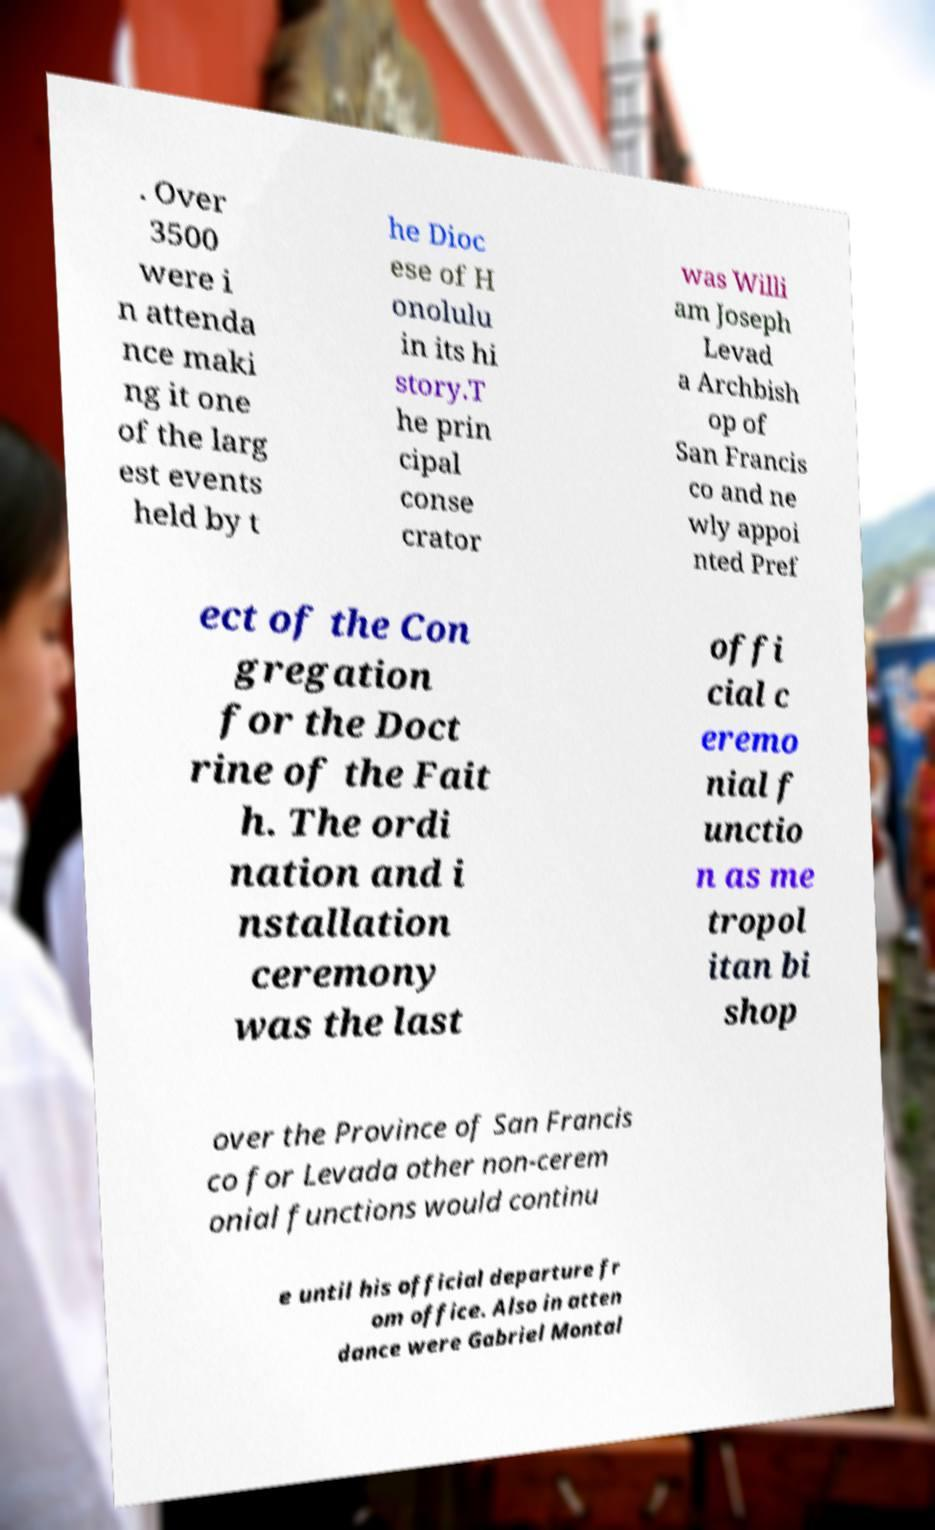Can you read and provide the text displayed in the image?This photo seems to have some interesting text. Can you extract and type it out for me? . Over 3500 were i n attenda nce maki ng it one of the larg est events held by t he Dioc ese of H onolulu in its hi story.T he prin cipal conse crator was Willi am Joseph Levad a Archbish op of San Francis co and ne wly appoi nted Pref ect of the Con gregation for the Doct rine of the Fait h. The ordi nation and i nstallation ceremony was the last offi cial c eremo nial f unctio n as me tropol itan bi shop over the Province of San Francis co for Levada other non-cerem onial functions would continu e until his official departure fr om office. Also in atten dance were Gabriel Montal 